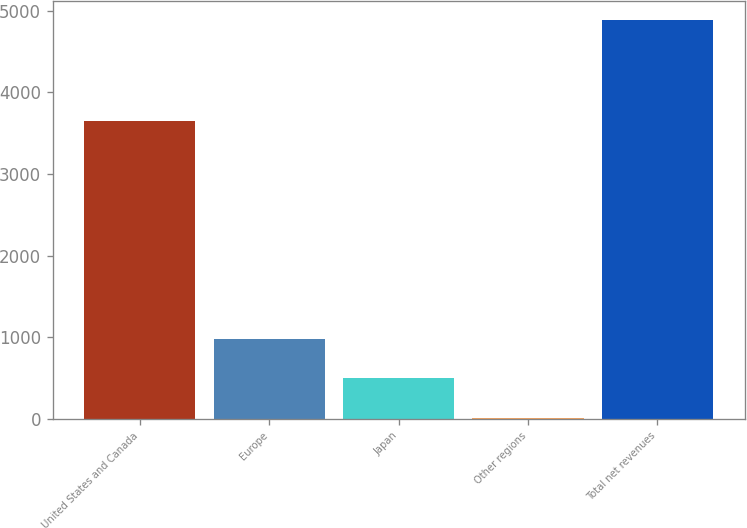Convert chart. <chart><loc_0><loc_0><loc_500><loc_500><bar_chart><fcel>United States and Canada<fcel>Europe<fcel>Japan<fcel>Other regions<fcel>Total net revenues<nl><fcel>3653.1<fcel>983.94<fcel>496.92<fcel>9.9<fcel>4880.1<nl></chart> 